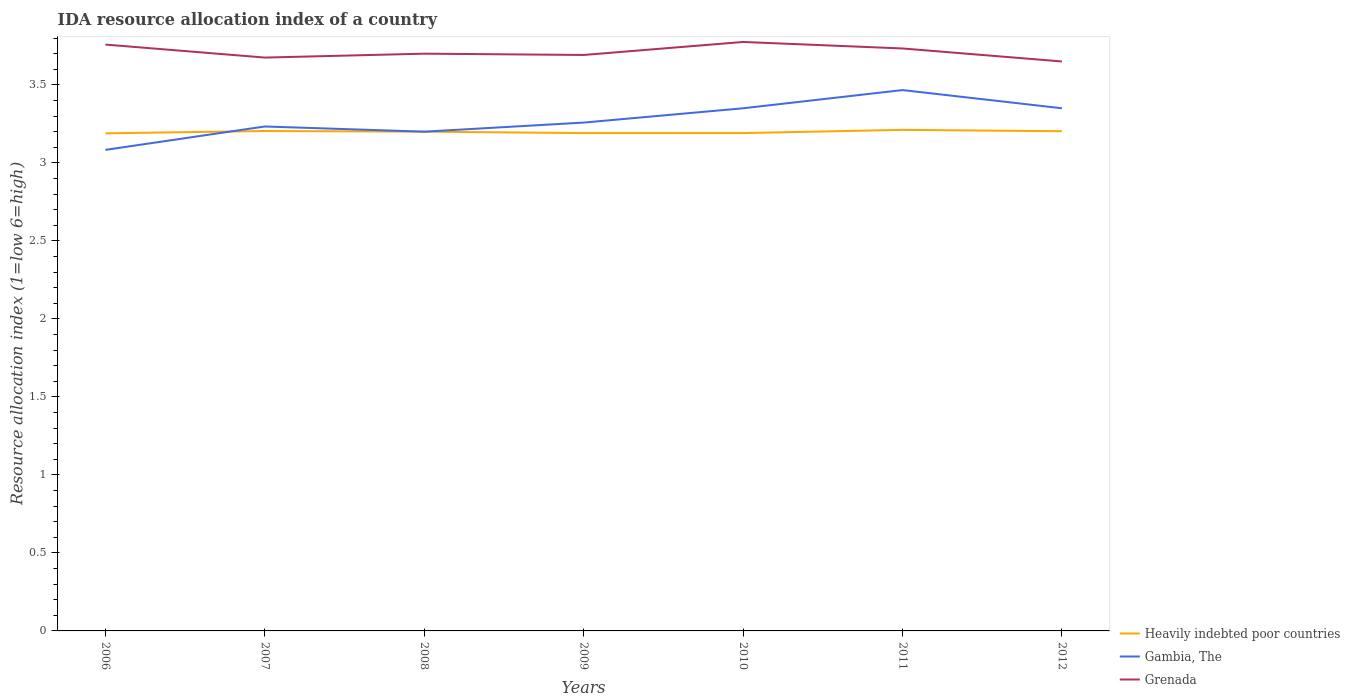How many different coloured lines are there?
Offer a very short reply. 3. Does the line corresponding to Gambia, The intersect with the line corresponding to Heavily indebted poor countries?
Provide a short and direct response. Yes. Is the number of lines equal to the number of legend labels?
Make the answer very short. Yes. Across all years, what is the maximum IDA resource allocation index in Gambia, The?
Provide a succinct answer. 3.08. In which year was the IDA resource allocation index in Grenada maximum?
Your answer should be compact. 2012. What is the total IDA resource allocation index in Gambia, The in the graph?
Your answer should be very brief. -0.12. What is the difference between the highest and the second highest IDA resource allocation index in Heavily indebted poor countries?
Give a very brief answer. 0.02. How many lines are there?
Your response must be concise. 3. What is the difference between two consecutive major ticks on the Y-axis?
Your answer should be compact. 0.5. Are the values on the major ticks of Y-axis written in scientific E-notation?
Provide a short and direct response. No. Does the graph contain any zero values?
Offer a terse response. No. Does the graph contain grids?
Keep it short and to the point. No. Where does the legend appear in the graph?
Provide a succinct answer. Bottom right. How many legend labels are there?
Give a very brief answer. 3. How are the legend labels stacked?
Make the answer very short. Vertical. What is the title of the graph?
Offer a very short reply. IDA resource allocation index of a country. Does "China" appear as one of the legend labels in the graph?
Provide a succinct answer. No. What is the label or title of the X-axis?
Make the answer very short. Years. What is the label or title of the Y-axis?
Offer a very short reply. Resource allocation index (1=low 6=high). What is the Resource allocation index (1=low 6=high) in Heavily indebted poor countries in 2006?
Provide a succinct answer. 3.19. What is the Resource allocation index (1=low 6=high) in Gambia, The in 2006?
Your answer should be compact. 3.08. What is the Resource allocation index (1=low 6=high) of Grenada in 2006?
Provide a succinct answer. 3.76. What is the Resource allocation index (1=low 6=high) of Heavily indebted poor countries in 2007?
Provide a succinct answer. 3.2. What is the Resource allocation index (1=low 6=high) of Gambia, The in 2007?
Offer a very short reply. 3.23. What is the Resource allocation index (1=low 6=high) in Grenada in 2007?
Make the answer very short. 3.67. What is the Resource allocation index (1=low 6=high) in Heavily indebted poor countries in 2008?
Offer a terse response. 3.2. What is the Resource allocation index (1=low 6=high) in Gambia, The in 2008?
Offer a very short reply. 3.2. What is the Resource allocation index (1=low 6=high) of Heavily indebted poor countries in 2009?
Offer a terse response. 3.19. What is the Resource allocation index (1=low 6=high) of Gambia, The in 2009?
Offer a very short reply. 3.26. What is the Resource allocation index (1=low 6=high) of Grenada in 2009?
Your answer should be very brief. 3.69. What is the Resource allocation index (1=low 6=high) of Heavily indebted poor countries in 2010?
Keep it short and to the point. 3.19. What is the Resource allocation index (1=low 6=high) of Gambia, The in 2010?
Your answer should be compact. 3.35. What is the Resource allocation index (1=low 6=high) in Grenada in 2010?
Your answer should be compact. 3.77. What is the Resource allocation index (1=low 6=high) in Heavily indebted poor countries in 2011?
Provide a short and direct response. 3.21. What is the Resource allocation index (1=low 6=high) in Gambia, The in 2011?
Your response must be concise. 3.47. What is the Resource allocation index (1=low 6=high) of Grenada in 2011?
Provide a succinct answer. 3.73. What is the Resource allocation index (1=low 6=high) in Heavily indebted poor countries in 2012?
Keep it short and to the point. 3.2. What is the Resource allocation index (1=low 6=high) of Gambia, The in 2012?
Your answer should be compact. 3.35. What is the Resource allocation index (1=low 6=high) of Grenada in 2012?
Your answer should be very brief. 3.65. Across all years, what is the maximum Resource allocation index (1=low 6=high) of Heavily indebted poor countries?
Your answer should be very brief. 3.21. Across all years, what is the maximum Resource allocation index (1=low 6=high) of Gambia, The?
Make the answer very short. 3.47. Across all years, what is the maximum Resource allocation index (1=low 6=high) of Grenada?
Make the answer very short. 3.77. Across all years, what is the minimum Resource allocation index (1=low 6=high) of Heavily indebted poor countries?
Provide a succinct answer. 3.19. Across all years, what is the minimum Resource allocation index (1=low 6=high) of Gambia, The?
Your answer should be very brief. 3.08. Across all years, what is the minimum Resource allocation index (1=low 6=high) in Grenada?
Provide a short and direct response. 3.65. What is the total Resource allocation index (1=low 6=high) of Heavily indebted poor countries in the graph?
Your answer should be very brief. 22.39. What is the total Resource allocation index (1=low 6=high) of Gambia, The in the graph?
Ensure brevity in your answer.  22.94. What is the total Resource allocation index (1=low 6=high) in Grenada in the graph?
Offer a terse response. 25.98. What is the difference between the Resource allocation index (1=low 6=high) of Heavily indebted poor countries in 2006 and that in 2007?
Provide a short and direct response. -0.01. What is the difference between the Resource allocation index (1=low 6=high) in Gambia, The in 2006 and that in 2007?
Your response must be concise. -0.15. What is the difference between the Resource allocation index (1=low 6=high) of Grenada in 2006 and that in 2007?
Give a very brief answer. 0.08. What is the difference between the Resource allocation index (1=low 6=high) of Heavily indebted poor countries in 2006 and that in 2008?
Provide a short and direct response. -0.01. What is the difference between the Resource allocation index (1=low 6=high) of Gambia, The in 2006 and that in 2008?
Your response must be concise. -0.12. What is the difference between the Resource allocation index (1=low 6=high) of Grenada in 2006 and that in 2008?
Ensure brevity in your answer.  0.06. What is the difference between the Resource allocation index (1=low 6=high) of Heavily indebted poor countries in 2006 and that in 2009?
Keep it short and to the point. -0. What is the difference between the Resource allocation index (1=low 6=high) of Gambia, The in 2006 and that in 2009?
Ensure brevity in your answer.  -0.17. What is the difference between the Resource allocation index (1=low 6=high) of Grenada in 2006 and that in 2009?
Offer a terse response. 0.07. What is the difference between the Resource allocation index (1=low 6=high) in Heavily indebted poor countries in 2006 and that in 2010?
Provide a succinct answer. -0. What is the difference between the Resource allocation index (1=low 6=high) in Gambia, The in 2006 and that in 2010?
Your answer should be compact. -0.27. What is the difference between the Resource allocation index (1=low 6=high) of Grenada in 2006 and that in 2010?
Give a very brief answer. -0.02. What is the difference between the Resource allocation index (1=low 6=high) of Heavily indebted poor countries in 2006 and that in 2011?
Offer a terse response. -0.02. What is the difference between the Resource allocation index (1=low 6=high) of Gambia, The in 2006 and that in 2011?
Offer a terse response. -0.38. What is the difference between the Resource allocation index (1=low 6=high) in Grenada in 2006 and that in 2011?
Provide a succinct answer. 0.03. What is the difference between the Resource allocation index (1=low 6=high) in Heavily indebted poor countries in 2006 and that in 2012?
Your answer should be compact. -0.01. What is the difference between the Resource allocation index (1=low 6=high) in Gambia, The in 2006 and that in 2012?
Ensure brevity in your answer.  -0.27. What is the difference between the Resource allocation index (1=low 6=high) in Grenada in 2006 and that in 2012?
Make the answer very short. 0.11. What is the difference between the Resource allocation index (1=low 6=high) of Heavily indebted poor countries in 2007 and that in 2008?
Provide a short and direct response. 0. What is the difference between the Resource allocation index (1=low 6=high) in Grenada in 2007 and that in 2008?
Offer a terse response. -0.03. What is the difference between the Resource allocation index (1=low 6=high) of Heavily indebted poor countries in 2007 and that in 2009?
Offer a very short reply. 0.01. What is the difference between the Resource allocation index (1=low 6=high) in Gambia, The in 2007 and that in 2009?
Make the answer very short. -0.03. What is the difference between the Resource allocation index (1=low 6=high) of Grenada in 2007 and that in 2009?
Your answer should be compact. -0.02. What is the difference between the Resource allocation index (1=low 6=high) of Heavily indebted poor countries in 2007 and that in 2010?
Keep it short and to the point. 0.01. What is the difference between the Resource allocation index (1=low 6=high) in Gambia, The in 2007 and that in 2010?
Your response must be concise. -0.12. What is the difference between the Resource allocation index (1=low 6=high) in Heavily indebted poor countries in 2007 and that in 2011?
Offer a very short reply. -0.01. What is the difference between the Resource allocation index (1=low 6=high) of Gambia, The in 2007 and that in 2011?
Provide a short and direct response. -0.23. What is the difference between the Resource allocation index (1=low 6=high) in Grenada in 2007 and that in 2011?
Offer a terse response. -0.06. What is the difference between the Resource allocation index (1=low 6=high) in Heavily indebted poor countries in 2007 and that in 2012?
Your answer should be compact. 0. What is the difference between the Resource allocation index (1=low 6=high) of Gambia, The in 2007 and that in 2012?
Provide a short and direct response. -0.12. What is the difference between the Resource allocation index (1=low 6=high) of Grenada in 2007 and that in 2012?
Offer a very short reply. 0.03. What is the difference between the Resource allocation index (1=low 6=high) in Heavily indebted poor countries in 2008 and that in 2009?
Offer a terse response. 0.01. What is the difference between the Resource allocation index (1=low 6=high) of Gambia, The in 2008 and that in 2009?
Make the answer very short. -0.06. What is the difference between the Resource allocation index (1=low 6=high) of Grenada in 2008 and that in 2009?
Your answer should be compact. 0.01. What is the difference between the Resource allocation index (1=low 6=high) of Heavily indebted poor countries in 2008 and that in 2010?
Offer a very short reply. 0.01. What is the difference between the Resource allocation index (1=low 6=high) of Grenada in 2008 and that in 2010?
Your response must be concise. -0.07. What is the difference between the Resource allocation index (1=low 6=high) in Heavily indebted poor countries in 2008 and that in 2011?
Keep it short and to the point. -0.01. What is the difference between the Resource allocation index (1=low 6=high) in Gambia, The in 2008 and that in 2011?
Provide a short and direct response. -0.27. What is the difference between the Resource allocation index (1=low 6=high) of Grenada in 2008 and that in 2011?
Ensure brevity in your answer.  -0.03. What is the difference between the Resource allocation index (1=low 6=high) of Heavily indebted poor countries in 2008 and that in 2012?
Provide a succinct answer. -0. What is the difference between the Resource allocation index (1=low 6=high) of Gambia, The in 2008 and that in 2012?
Keep it short and to the point. -0.15. What is the difference between the Resource allocation index (1=low 6=high) of Grenada in 2008 and that in 2012?
Your response must be concise. 0.05. What is the difference between the Resource allocation index (1=low 6=high) in Heavily indebted poor countries in 2009 and that in 2010?
Keep it short and to the point. 0. What is the difference between the Resource allocation index (1=low 6=high) of Gambia, The in 2009 and that in 2010?
Make the answer very short. -0.09. What is the difference between the Resource allocation index (1=low 6=high) in Grenada in 2009 and that in 2010?
Give a very brief answer. -0.08. What is the difference between the Resource allocation index (1=low 6=high) of Heavily indebted poor countries in 2009 and that in 2011?
Make the answer very short. -0.02. What is the difference between the Resource allocation index (1=low 6=high) of Gambia, The in 2009 and that in 2011?
Provide a succinct answer. -0.21. What is the difference between the Resource allocation index (1=low 6=high) of Grenada in 2009 and that in 2011?
Offer a terse response. -0.04. What is the difference between the Resource allocation index (1=low 6=high) of Heavily indebted poor countries in 2009 and that in 2012?
Offer a terse response. -0.01. What is the difference between the Resource allocation index (1=low 6=high) of Gambia, The in 2009 and that in 2012?
Keep it short and to the point. -0.09. What is the difference between the Resource allocation index (1=low 6=high) in Grenada in 2009 and that in 2012?
Keep it short and to the point. 0.04. What is the difference between the Resource allocation index (1=low 6=high) in Heavily indebted poor countries in 2010 and that in 2011?
Offer a very short reply. -0.02. What is the difference between the Resource allocation index (1=low 6=high) in Gambia, The in 2010 and that in 2011?
Give a very brief answer. -0.12. What is the difference between the Resource allocation index (1=low 6=high) in Grenada in 2010 and that in 2011?
Provide a succinct answer. 0.04. What is the difference between the Resource allocation index (1=low 6=high) in Heavily indebted poor countries in 2010 and that in 2012?
Keep it short and to the point. -0.01. What is the difference between the Resource allocation index (1=low 6=high) in Heavily indebted poor countries in 2011 and that in 2012?
Provide a succinct answer. 0.01. What is the difference between the Resource allocation index (1=low 6=high) in Gambia, The in 2011 and that in 2012?
Ensure brevity in your answer.  0.12. What is the difference between the Resource allocation index (1=low 6=high) of Grenada in 2011 and that in 2012?
Give a very brief answer. 0.08. What is the difference between the Resource allocation index (1=low 6=high) of Heavily indebted poor countries in 2006 and the Resource allocation index (1=low 6=high) of Gambia, The in 2007?
Offer a terse response. -0.04. What is the difference between the Resource allocation index (1=low 6=high) of Heavily indebted poor countries in 2006 and the Resource allocation index (1=low 6=high) of Grenada in 2007?
Your answer should be compact. -0.49. What is the difference between the Resource allocation index (1=low 6=high) in Gambia, The in 2006 and the Resource allocation index (1=low 6=high) in Grenada in 2007?
Keep it short and to the point. -0.59. What is the difference between the Resource allocation index (1=low 6=high) of Heavily indebted poor countries in 2006 and the Resource allocation index (1=low 6=high) of Gambia, The in 2008?
Give a very brief answer. -0.01. What is the difference between the Resource allocation index (1=low 6=high) in Heavily indebted poor countries in 2006 and the Resource allocation index (1=low 6=high) in Grenada in 2008?
Offer a very short reply. -0.51. What is the difference between the Resource allocation index (1=low 6=high) in Gambia, The in 2006 and the Resource allocation index (1=low 6=high) in Grenada in 2008?
Offer a terse response. -0.62. What is the difference between the Resource allocation index (1=low 6=high) in Heavily indebted poor countries in 2006 and the Resource allocation index (1=low 6=high) in Gambia, The in 2009?
Ensure brevity in your answer.  -0.07. What is the difference between the Resource allocation index (1=low 6=high) of Heavily indebted poor countries in 2006 and the Resource allocation index (1=low 6=high) of Grenada in 2009?
Ensure brevity in your answer.  -0.5. What is the difference between the Resource allocation index (1=low 6=high) of Gambia, The in 2006 and the Resource allocation index (1=low 6=high) of Grenada in 2009?
Your answer should be very brief. -0.61. What is the difference between the Resource allocation index (1=low 6=high) of Heavily indebted poor countries in 2006 and the Resource allocation index (1=low 6=high) of Gambia, The in 2010?
Give a very brief answer. -0.16. What is the difference between the Resource allocation index (1=low 6=high) in Heavily indebted poor countries in 2006 and the Resource allocation index (1=low 6=high) in Grenada in 2010?
Your response must be concise. -0.59. What is the difference between the Resource allocation index (1=low 6=high) of Gambia, The in 2006 and the Resource allocation index (1=low 6=high) of Grenada in 2010?
Offer a terse response. -0.69. What is the difference between the Resource allocation index (1=low 6=high) of Heavily indebted poor countries in 2006 and the Resource allocation index (1=low 6=high) of Gambia, The in 2011?
Keep it short and to the point. -0.28. What is the difference between the Resource allocation index (1=low 6=high) of Heavily indebted poor countries in 2006 and the Resource allocation index (1=low 6=high) of Grenada in 2011?
Give a very brief answer. -0.54. What is the difference between the Resource allocation index (1=low 6=high) in Gambia, The in 2006 and the Resource allocation index (1=low 6=high) in Grenada in 2011?
Your response must be concise. -0.65. What is the difference between the Resource allocation index (1=low 6=high) in Heavily indebted poor countries in 2006 and the Resource allocation index (1=low 6=high) in Gambia, The in 2012?
Your answer should be very brief. -0.16. What is the difference between the Resource allocation index (1=low 6=high) of Heavily indebted poor countries in 2006 and the Resource allocation index (1=low 6=high) of Grenada in 2012?
Your response must be concise. -0.46. What is the difference between the Resource allocation index (1=low 6=high) in Gambia, The in 2006 and the Resource allocation index (1=low 6=high) in Grenada in 2012?
Provide a succinct answer. -0.57. What is the difference between the Resource allocation index (1=low 6=high) in Heavily indebted poor countries in 2007 and the Resource allocation index (1=low 6=high) in Gambia, The in 2008?
Offer a terse response. 0. What is the difference between the Resource allocation index (1=low 6=high) of Heavily indebted poor countries in 2007 and the Resource allocation index (1=low 6=high) of Grenada in 2008?
Offer a terse response. -0.5. What is the difference between the Resource allocation index (1=low 6=high) of Gambia, The in 2007 and the Resource allocation index (1=low 6=high) of Grenada in 2008?
Give a very brief answer. -0.47. What is the difference between the Resource allocation index (1=low 6=high) of Heavily indebted poor countries in 2007 and the Resource allocation index (1=low 6=high) of Gambia, The in 2009?
Your answer should be very brief. -0.05. What is the difference between the Resource allocation index (1=low 6=high) in Heavily indebted poor countries in 2007 and the Resource allocation index (1=low 6=high) in Grenada in 2009?
Your answer should be very brief. -0.49. What is the difference between the Resource allocation index (1=low 6=high) of Gambia, The in 2007 and the Resource allocation index (1=low 6=high) of Grenada in 2009?
Your answer should be compact. -0.46. What is the difference between the Resource allocation index (1=low 6=high) of Heavily indebted poor countries in 2007 and the Resource allocation index (1=low 6=high) of Gambia, The in 2010?
Your answer should be compact. -0.15. What is the difference between the Resource allocation index (1=low 6=high) in Heavily indebted poor countries in 2007 and the Resource allocation index (1=low 6=high) in Grenada in 2010?
Your response must be concise. -0.57. What is the difference between the Resource allocation index (1=low 6=high) of Gambia, The in 2007 and the Resource allocation index (1=low 6=high) of Grenada in 2010?
Your answer should be compact. -0.54. What is the difference between the Resource allocation index (1=low 6=high) of Heavily indebted poor countries in 2007 and the Resource allocation index (1=low 6=high) of Gambia, The in 2011?
Make the answer very short. -0.26. What is the difference between the Resource allocation index (1=low 6=high) in Heavily indebted poor countries in 2007 and the Resource allocation index (1=low 6=high) in Grenada in 2011?
Your answer should be compact. -0.53. What is the difference between the Resource allocation index (1=low 6=high) in Gambia, The in 2007 and the Resource allocation index (1=low 6=high) in Grenada in 2011?
Provide a succinct answer. -0.5. What is the difference between the Resource allocation index (1=low 6=high) of Heavily indebted poor countries in 2007 and the Resource allocation index (1=low 6=high) of Gambia, The in 2012?
Offer a terse response. -0.15. What is the difference between the Resource allocation index (1=low 6=high) in Heavily indebted poor countries in 2007 and the Resource allocation index (1=low 6=high) in Grenada in 2012?
Your answer should be very brief. -0.45. What is the difference between the Resource allocation index (1=low 6=high) in Gambia, The in 2007 and the Resource allocation index (1=low 6=high) in Grenada in 2012?
Ensure brevity in your answer.  -0.42. What is the difference between the Resource allocation index (1=low 6=high) in Heavily indebted poor countries in 2008 and the Resource allocation index (1=low 6=high) in Gambia, The in 2009?
Offer a very short reply. -0.06. What is the difference between the Resource allocation index (1=low 6=high) in Heavily indebted poor countries in 2008 and the Resource allocation index (1=low 6=high) in Grenada in 2009?
Offer a very short reply. -0.49. What is the difference between the Resource allocation index (1=low 6=high) in Gambia, The in 2008 and the Resource allocation index (1=low 6=high) in Grenada in 2009?
Ensure brevity in your answer.  -0.49. What is the difference between the Resource allocation index (1=low 6=high) of Heavily indebted poor countries in 2008 and the Resource allocation index (1=low 6=high) of Grenada in 2010?
Provide a short and direct response. -0.57. What is the difference between the Resource allocation index (1=low 6=high) in Gambia, The in 2008 and the Resource allocation index (1=low 6=high) in Grenada in 2010?
Ensure brevity in your answer.  -0.57. What is the difference between the Resource allocation index (1=low 6=high) in Heavily indebted poor countries in 2008 and the Resource allocation index (1=low 6=high) in Gambia, The in 2011?
Offer a very short reply. -0.27. What is the difference between the Resource allocation index (1=low 6=high) in Heavily indebted poor countries in 2008 and the Resource allocation index (1=low 6=high) in Grenada in 2011?
Make the answer very short. -0.53. What is the difference between the Resource allocation index (1=low 6=high) in Gambia, The in 2008 and the Resource allocation index (1=low 6=high) in Grenada in 2011?
Offer a terse response. -0.53. What is the difference between the Resource allocation index (1=low 6=high) in Heavily indebted poor countries in 2008 and the Resource allocation index (1=low 6=high) in Gambia, The in 2012?
Make the answer very short. -0.15. What is the difference between the Resource allocation index (1=low 6=high) in Heavily indebted poor countries in 2008 and the Resource allocation index (1=low 6=high) in Grenada in 2012?
Your response must be concise. -0.45. What is the difference between the Resource allocation index (1=low 6=high) in Gambia, The in 2008 and the Resource allocation index (1=low 6=high) in Grenada in 2012?
Your response must be concise. -0.45. What is the difference between the Resource allocation index (1=low 6=high) in Heavily indebted poor countries in 2009 and the Resource allocation index (1=low 6=high) in Gambia, The in 2010?
Your response must be concise. -0.16. What is the difference between the Resource allocation index (1=low 6=high) in Heavily indebted poor countries in 2009 and the Resource allocation index (1=low 6=high) in Grenada in 2010?
Make the answer very short. -0.58. What is the difference between the Resource allocation index (1=low 6=high) in Gambia, The in 2009 and the Resource allocation index (1=low 6=high) in Grenada in 2010?
Offer a very short reply. -0.52. What is the difference between the Resource allocation index (1=low 6=high) in Heavily indebted poor countries in 2009 and the Resource allocation index (1=low 6=high) in Gambia, The in 2011?
Provide a succinct answer. -0.28. What is the difference between the Resource allocation index (1=low 6=high) in Heavily indebted poor countries in 2009 and the Resource allocation index (1=low 6=high) in Grenada in 2011?
Offer a terse response. -0.54. What is the difference between the Resource allocation index (1=low 6=high) of Gambia, The in 2009 and the Resource allocation index (1=low 6=high) of Grenada in 2011?
Offer a very short reply. -0.47. What is the difference between the Resource allocation index (1=low 6=high) of Heavily indebted poor countries in 2009 and the Resource allocation index (1=low 6=high) of Gambia, The in 2012?
Make the answer very short. -0.16. What is the difference between the Resource allocation index (1=low 6=high) of Heavily indebted poor countries in 2009 and the Resource allocation index (1=low 6=high) of Grenada in 2012?
Keep it short and to the point. -0.46. What is the difference between the Resource allocation index (1=low 6=high) in Gambia, The in 2009 and the Resource allocation index (1=low 6=high) in Grenada in 2012?
Ensure brevity in your answer.  -0.39. What is the difference between the Resource allocation index (1=low 6=high) in Heavily indebted poor countries in 2010 and the Resource allocation index (1=low 6=high) in Gambia, The in 2011?
Ensure brevity in your answer.  -0.28. What is the difference between the Resource allocation index (1=low 6=high) of Heavily indebted poor countries in 2010 and the Resource allocation index (1=low 6=high) of Grenada in 2011?
Provide a succinct answer. -0.54. What is the difference between the Resource allocation index (1=low 6=high) of Gambia, The in 2010 and the Resource allocation index (1=low 6=high) of Grenada in 2011?
Give a very brief answer. -0.38. What is the difference between the Resource allocation index (1=low 6=high) in Heavily indebted poor countries in 2010 and the Resource allocation index (1=low 6=high) in Gambia, The in 2012?
Your answer should be very brief. -0.16. What is the difference between the Resource allocation index (1=low 6=high) in Heavily indebted poor countries in 2010 and the Resource allocation index (1=low 6=high) in Grenada in 2012?
Make the answer very short. -0.46. What is the difference between the Resource allocation index (1=low 6=high) of Heavily indebted poor countries in 2011 and the Resource allocation index (1=low 6=high) of Gambia, The in 2012?
Your answer should be compact. -0.14. What is the difference between the Resource allocation index (1=low 6=high) of Heavily indebted poor countries in 2011 and the Resource allocation index (1=low 6=high) of Grenada in 2012?
Provide a short and direct response. -0.44. What is the difference between the Resource allocation index (1=low 6=high) in Gambia, The in 2011 and the Resource allocation index (1=low 6=high) in Grenada in 2012?
Give a very brief answer. -0.18. What is the average Resource allocation index (1=low 6=high) in Heavily indebted poor countries per year?
Keep it short and to the point. 3.2. What is the average Resource allocation index (1=low 6=high) in Gambia, The per year?
Provide a succinct answer. 3.28. What is the average Resource allocation index (1=low 6=high) in Grenada per year?
Provide a succinct answer. 3.71. In the year 2006, what is the difference between the Resource allocation index (1=low 6=high) in Heavily indebted poor countries and Resource allocation index (1=low 6=high) in Gambia, The?
Make the answer very short. 0.11. In the year 2006, what is the difference between the Resource allocation index (1=low 6=high) in Heavily indebted poor countries and Resource allocation index (1=low 6=high) in Grenada?
Provide a succinct answer. -0.57. In the year 2006, what is the difference between the Resource allocation index (1=low 6=high) in Gambia, The and Resource allocation index (1=low 6=high) in Grenada?
Your answer should be very brief. -0.68. In the year 2007, what is the difference between the Resource allocation index (1=low 6=high) in Heavily indebted poor countries and Resource allocation index (1=low 6=high) in Gambia, The?
Give a very brief answer. -0.03. In the year 2007, what is the difference between the Resource allocation index (1=low 6=high) in Heavily indebted poor countries and Resource allocation index (1=low 6=high) in Grenada?
Offer a very short reply. -0.47. In the year 2007, what is the difference between the Resource allocation index (1=low 6=high) of Gambia, The and Resource allocation index (1=low 6=high) of Grenada?
Your answer should be compact. -0.44. In the year 2008, what is the difference between the Resource allocation index (1=low 6=high) of Heavily indebted poor countries and Resource allocation index (1=low 6=high) of Gambia, The?
Ensure brevity in your answer.  0. In the year 2008, what is the difference between the Resource allocation index (1=low 6=high) of Heavily indebted poor countries and Resource allocation index (1=low 6=high) of Grenada?
Your answer should be compact. -0.5. In the year 2008, what is the difference between the Resource allocation index (1=low 6=high) of Gambia, The and Resource allocation index (1=low 6=high) of Grenada?
Offer a terse response. -0.5. In the year 2009, what is the difference between the Resource allocation index (1=low 6=high) in Heavily indebted poor countries and Resource allocation index (1=low 6=high) in Gambia, The?
Give a very brief answer. -0.07. In the year 2009, what is the difference between the Resource allocation index (1=low 6=high) in Heavily indebted poor countries and Resource allocation index (1=low 6=high) in Grenada?
Give a very brief answer. -0.5. In the year 2009, what is the difference between the Resource allocation index (1=low 6=high) of Gambia, The and Resource allocation index (1=low 6=high) of Grenada?
Offer a terse response. -0.43. In the year 2010, what is the difference between the Resource allocation index (1=low 6=high) in Heavily indebted poor countries and Resource allocation index (1=low 6=high) in Gambia, The?
Your answer should be very brief. -0.16. In the year 2010, what is the difference between the Resource allocation index (1=low 6=high) in Heavily indebted poor countries and Resource allocation index (1=low 6=high) in Grenada?
Your answer should be compact. -0.58. In the year 2010, what is the difference between the Resource allocation index (1=low 6=high) of Gambia, The and Resource allocation index (1=low 6=high) of Grenada?
Your response must be concise. -0.42. In the year 2011, what is the difference between the Resource allocation index (1=low 6=high) in Heavily indebted poor countries and Resource allocation index (1=low 6=high) in Gambia, The?
Your response must be concise. -0.26. In the year 2011, what is the difference between the Resource allocation index (1=low 6=high) in Heavily indebted poor countries and Resource allocation index (1=low 6=high) in Grenada?
Your answer should be very brief. -0.52. In the year 2011, what is the difference between the Resource allocation index (1=low 6=high) in Gambia, The and Resource allocation index (1=low 6=high) in Grenada?
Your response must be concise. -0.27. In the year 2012, what is the difference between the Resource allocation index (1=low 6=high) in Heavily indebted poor countries and Resource allocation index (1=low 6=high) in Gambia, The?
Your answer should be very brief. -0.15. In the year 2012, what is the difference between the Resource allocation index (1=low 6=high) of Heavily indebted poor countries and Resource allocation index (1=low 6=high) of Grenada?
Make the answer very short. -0.45. In the year 2012, what is the difference between the Resource allocation index (1=low 6=high) in Gambia, The and Resource allocation index (1=low 6=high) in Grenada?
Your answer should be compact. -0.3. What is the ratio of the Resource allocation index (1=low 6=high) in Heavily indebted poor countries in 2006 to that in 2007?
Give a very brief answer. 1. What is the ratio of the Resource allocation index (1=low 6=high) of Gambia, The in 2006 to that in 2007?
Ensure brevity in your answer.  0.95. What is the ratio of the Resource allocation index (1=low 6=high) of Grenada in 2006 to that in 2007?
Offer a terse response. 1.02. What is the ratio of the Resource allocation index (1=low 6=high) in Gambia, The in 2006 to that in 2008?
Offer a terse response. 0.96. What is the ratio of the Resource allocation index (1=low 6=high) of Grenada in 2006 to that in 2008?
Ensure brevity in your answer.  1.02. What is the ratio of the Resource allocation index (1=low 6=high) in Gambia, The in 2006 to that in 2009?
Your response must be concise. 0.95. What is the ratio of the Resource allocation index (1=low 6=high) of Grenada in 2006 to that in 2009?
Your answer should be very brief. 1.02. What is the ratio of the Resource allocation index (1=low 6=high) of Heavily indebted poor countries in 2006 to that in 2010?
Your response must be concise. 1. What is the ratio of the Resource allocation index (1=low 6=high) of Gambia, The in 2006 to that in 2010?
Offer a very short reply. 0.92. What is the ratio of the Resource allocation index (1=low 6=high) of Grenada in 2006 to that in 2010?
Your answer should be compact. 1. What is the ratio of the Resource allocation index (1=low 6=high) in Heavily indebted poor countries in 2006 to that in 2011?
Your response must be concise. 0.99. What is the ratio of the Resource allocation index (1=low 6=high) in Gambia, The in 2006 to that in 2011?
Your answer should be compact. 0.89. What is the ratio of the Resource allocation index (1=low 6=high) of Gambia, The in 2006 to that in 2012?
Ensure brevity in your answer.  0.92. What is the ratio of the Resource allocation index (1=low 6=high) in Grenada in 2006 to that in 2012?
Offer a terse response. 1.03. What is the ratio of the Resource allocation index (1=low 6=high) in Gambia, The in 2007 to that in 2008?
Give a very brief answer. 1.01. What is the ratio of the Resource allocation index (1=low 6=high) of Gambia, The in 2007 to that in 2009?
Give a very brief answer. 0.99. What is the ratio of the Resource allocation index (1=low 6=high) in Grenada in 2007 to that in 2009?
Provide a short and direct response. 1. What is the ratio of the Resource allocation index (1=low 6=high) in Heavily indebted poor countries in 2007 to that in 2010?
Your answer should be very brief. 1. What is the ratio of the Resource allocation index (1=low 6=high) of Gambia, The in 2007 to that in 2010?
Offer a very short reply. 0.97. What is the ratio of the Resource allocation index (1=low 6=high) in Grenada in 2007 to that in 2010?
Provide a short and direct response. 0.97. What is the ratio of the Resource allocation index (1=low 6=high) of Gambia, The in 2007 to that in 2011?
Ensure brevity in your answer.  0.93. What is the ratio of the Resource allocation index (1=low 6=high) of Grenada in 2007 to that in 2011?
Offer a very short reply. 0.98. What is the ratio of the Resource allocation index (1=low 6=high) of Heavily indebted poor countries in 2007 to that in 2012?
Offer a terse response. 1. What is the ratio of the Resource allocation index (1=low 6=high) in Gambia, The in 2007 to that in 2012?
Offer a terse response. 0.97. What is the ratio of the Resource allocation index (1=low 6=high) of Grenada in 2007 to that in 2012?
Keep it short and to the point. 1.01. What is the ratio of the Resource allocation index (1=low 6=high) of Gambia, The in 2008 to that in 2009?
Your answer should be very brief. 0.98. What is the ratio of the Resource allocation index (1=low 6=high) of Grenada in 2008 to that in 2009?
Your answer should be compact. 1. What is the ratio of the Resource allocation index (1=low 6=high) of Gambia, The in 2008 to that in 2010?
Keep it short and to the point. 0.96. What is the ratio of the Resource allocation index (1=low 6=high) of Grenada in 2008 to that in 2010?
Provide a short and direct response. 0.98. What is the ratio of the Resource allocation index (1=low 6=high) in Heavily indebted poor countries in 2008 to that in 2011?
Make the answer very short. 1. What is the ratio of the Resource allocation index (1=low 6=high) of Gambia, The in 2008 to that in 2011?
Make the answer very short. 0.92. What is the ratio of the Resource allocation index (1=low 6=high) in Grenada in 2008 to that in 2011?
Provide a succinct answer. 0.99. What is the ratio of the Resource allocation index (1=low 6=high) of Heavily indebted poor countries in 2008 to that in 2012?
Ensure brevity in your answer.  1. What is the ratio of the Resource allocation index (1=low 6=high) in Gambia, The in 2008 to that in 2012?
Your answer should be compact. 0.96. What is the ratio of the Resource allocation index (1=low 6=high) in Grenada in 2008 to that in 2012?
Your answer should be very brief. 1.01. What is the ratio of the Resource allocation index (1=low 6=high) of Gambia, The in 2009 to that in 2010?
Keep it short and to the point. 0.97. What is the ratio of the Resource allocation index (1=low 6=high) in Grenada in 2009 to that in 2010?
Give a very brief answer. 0.98. What is the ratio of the Resource allocation index (1=low 6=high) in Gambia, The in 2009 to that in 2011?
Your answer should be very brief. 0.94. What is the ratio of the Resource allocation index (1=low 6=high) of Heavily indebted poor countries in 2009 to that in 2012?
Your answer should be compact. 1. What is the ratio of the Resource allocation index (1=low 6=high) of Gambia, The in 2009 to that in 2012?
Your answer should be very brief. 0.97. What is the ratio of the Resource allocation index (1=low 6=high) of Grenada in 2009 to that in 2012?
Offer a very short reply. 1.01. What is the ratio of the Resource allocation index (1=low 6=high) in Heavily indebted poor countries in 2010 to that in 2011?
Offer a very short reply. 0.99. What is the ratio of the Resource allocation index (1=low 6=high) of Gambia, The in 2010 to that in 2011?
Offer a terse response. 0.97. What is the ratio of the Resource allocation index (1=low 6=high) of Grenada in 2010 to that in 2011?
Offer a very short reply. 1.01. What is the ratio of the Resource allocation index (1=low 6=high) in Heavily indebted poor countries in 2010 to that in 2012?
Provide a succinct answer. 1. What is the ratio of the Resource allocation index (1=low 6=high) in Gambia, The in 2010 to that in 2012?
Make the answer very short. 1. What is the ratio of the Resource allocation index (1=low 6=high) in Grenada in 2010 to that in 2012?
Give a very brief answer. 1.03. What is the ratio of the Resource allocation index (1=low 6=high) in Gambia, The in 2011 to that in 2012?
Make the answer very short. 1.03. What is the ratio of the Resource allocation index (1=low 6=high) of Grenada in 2011 to that in 2012?
Make the answer very short. 1.02. What is the difference between the highest and the second highest Resource allocation index (1=low 6=high) in Heavily indebted poor countries?
Offer a terse response. 0.01. What is the difference between the highest and the second highest Resource allocation index (1=low 6=high) of Gambia, The?
Provide a succinct answer. 0.12. What is the difference between the highest and the second highest Resource allocation index (1=low 6=high) of Grenada?
Ensure brevity in your answer.  0.02. What is the difference between the highest and the lowest Resource allocation index (1=low 6=high) in Heavily indebted poor countries?
Provide a short and direct response. 0.02. What is the difference between the highest and the lowest Resource allocation index (1=low 6=high) in Gambia, The?
Offer a very short reply. 0.38. 